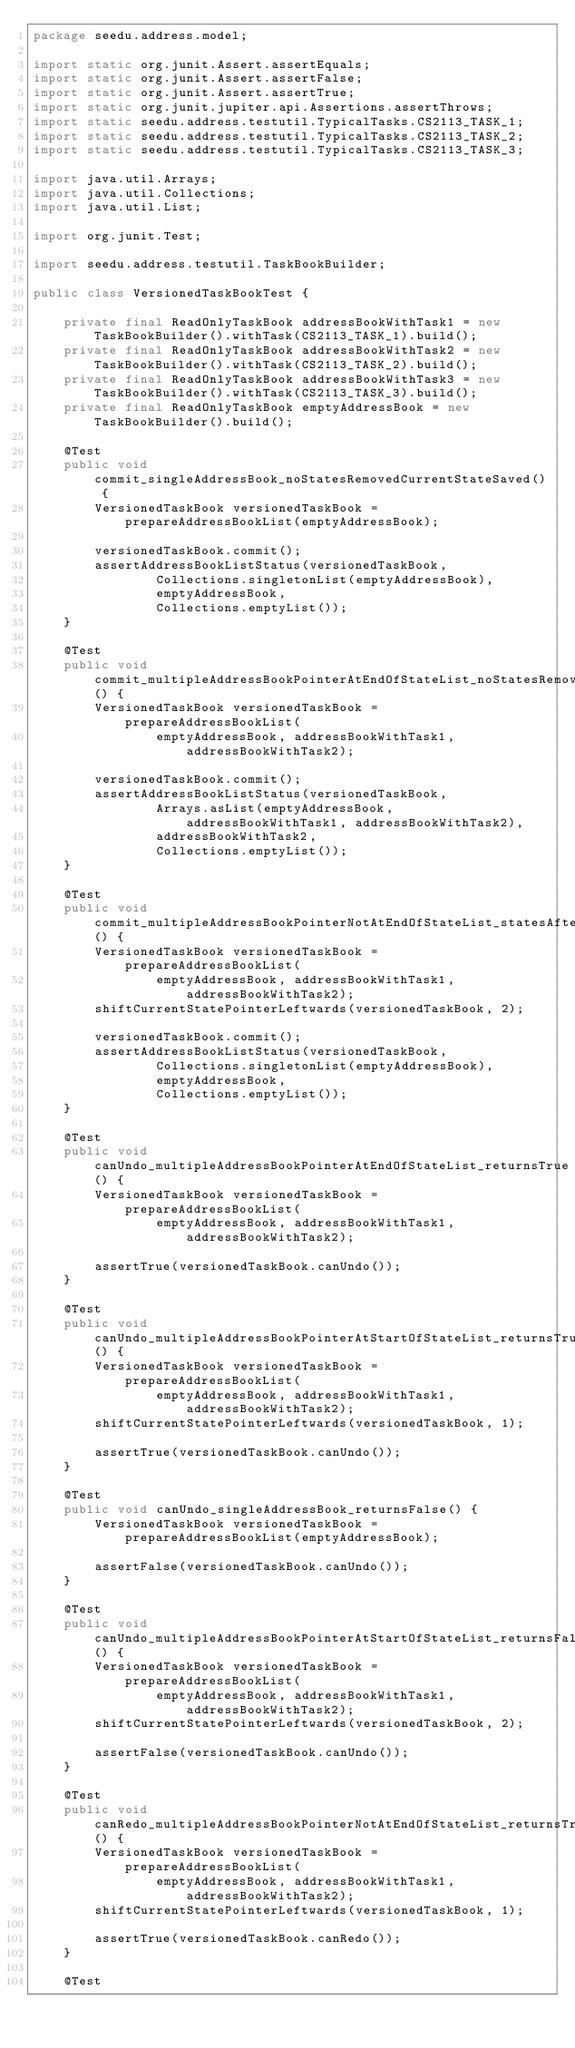Convert code to text. <code><loc_0><loc_0><loc_500><loc_500><_Java_>package seedu.address.model;

import static org.junit.Assert.assertEquals;
import static org.junit.Assert.assertFalse;
import static org.junit.Assert.assertTrue;
import static org.junit.jupiter.api.Assertions.assertThrows;
import static seedu.address.testutil.TypicalTasks.CS2113_TASK_1;
import static seedu.address.testutil.TypicalTasks.CS2113_TASK_2;
import static seedu.address.testutil.TypicalTasks.CS2113_TASK_3;

import java.util.Arrays;
import java.util.Collections;
import java.util.List;

import org.junit.Test;

import seedu.address.testutil.TaskBookBuilder;

public class VersionedTaskBookTest {

    private final ReadOnlyTaskBook addressBookWithTask1 = new TaskBookBuilder().withTask(CS2113_TASK_1).build();
    private final ReadOnlyTaskBook addressBookWithTask2 = new TaskBookBuilder().withTask(CS2113_TASK_2).build();
    private final ReadOnlyTaskBook addressBookWithTask3 = new TaskBookBuilder().withTask(CS2113_TASK_3).build();
    private final ReadOnlyTaskBook emptyAddressBook = new TaskBookBuilder().build();

    @Test
    public void commit_singleAddressBook_noStatesRemovedCurrentStateSaved() {
        VersionedTaskBook versionedTaskBook = prepareAddressBookList(emptyAddressBook);

        versionedTaskBook.commit();
        assertAddressBookListStatus(versionedTaskBook,
                Collections.singletonList(emptyAddressBook),
                emptyAddressBook,
                Collections.emptyList());
    }

    @Test
    public void commit_multipleAddressBookPointerAtEndOfStateList_noStatesRemovedCurrentStateSaved() {
        VersionedTaskBook versionedTaskBook = prepareAddressBookList(
                emptyAddressBook, addressBookWithTask1, addressBookWithTask2);

        versionedTaskBook.commit();
        assertAddressBookListStatus(versionedTaskBook,
                Arrays.asList(emptyAddressBook, addressBookWithTask1, addressBookWithTask2),
                addressBookWithTask2,
                Collections.emptyList());
    }

    @Test
    public void commit_multipleAddressBookPointerNotAtEndOfStateList_statesAfterPointerRemovedCurrentStateSaved() {
        VersionedTaskBook versionedTaskBook = prepareAddressBookList(
                emptyAddressBook, addressBookWithTask1, addressBookWithTask2);
        shiftCurrentStatePointerLeftwards(versionedTaskBook, 2);

        versionedTaskBook.commit();
        assertAddressBookListStatus(versionedTaskBook,
                Collections.singletonList(emptyAddressBook),
                emptyAddressBook,
                Collections.emptyList());
    }

    @Test
    public void canUndo_multipleAddressBookPointerAtEndOfStateList_returnsTrue() {
        VersionedTaskBook versionedTaskBook = prepareAddressBookList(
                emptyAddressBook, addressBookWithTask1, addressBookWithTask2);

        assertTrue(versionedTaskBook.canUndo());
    }

    @Test
    public void canUndo_multipleAddressBookPointerAtStartOfStateList_returnsTrue() {
        VersionedTaskBook versionedTaskBook = prepareAddressBookList(
                emptyAddressBook, addressBookWithTask1, addressBookWithTask2);
        shiftCurrentStatePointerLeftwards(versionedTaskBook, 1);

        assertTrue(versionedTaskBook.canUndo());
    }

    @Test
    public void canUndo_singleAddressBook_returnsFalse() {
        VersionedTaskBook versionedTaskBook = prepareAddressBookList(emptyAddressBook);

        assertFalse(versionedTaskBook.canUndo());
    }

    @Test
    public void canUndo_multipleAddressBookPointerAtStartOfStateList_returnsFalse() {
        VersionedTaskBook versionedTaskBook = prepareAddressBookList(
                emptyAddressBook, addressBookWithTask1, addressBookWithTask2);
        shiftCurrentStatePointerLeftwards(versionedTaskBook, 2);

        assertFalse(versionedTaskBook.canUndo());
    }

    @Test
    public void canRedo_multipleAddressBookPointerNotAtEndOfStateList_returnsTrue() {
        VersionedTaskBook versionedTaskBook = prepareAddressBookList(
                emptyAddressBook, addressBookWithTask1, addressBookWithTask2);
        shiftCurrentStatePointerLeftwards(versionedTaskBook, 1);

        assertTrue(versionedTaskBook.canRedo());
    }

    @Test</code> 